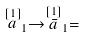Convert formula to latex. <formula><loc_0><loc_0><loc_500><loc_500>\stackrel { [ 1 ] } { a } _ { 1 } \rightarrow \stackrel { [ 1 ] } { \bar { a } } _ { 1 } =</formula> 